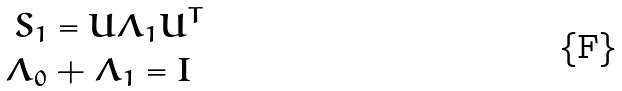<formula> <loc_0><loc_0><loc_500><loc_500>S _ { 1 } & = U \Lambda _ { 1 } U ^ { T } \\ \Lambda _ { 0 } & + \Lambda _ { 1 } = I</formula> 